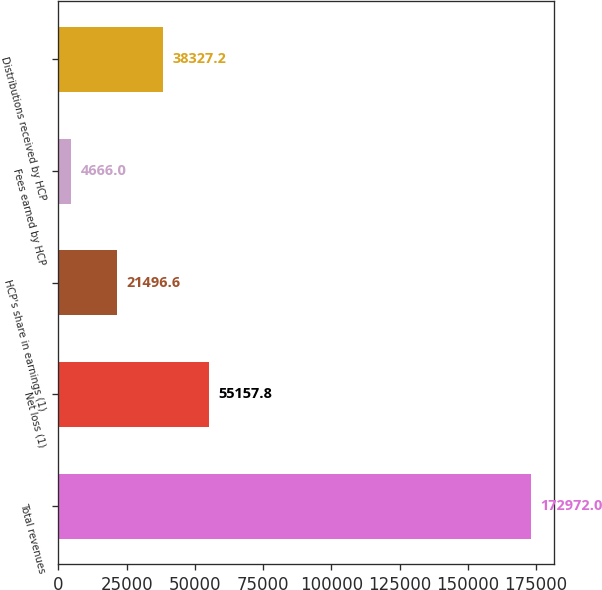Convert chart. <chart><loc_0><loc_0><loc_500><loc_500><bar_chart><fcel>Total revenues<fcel>Net loss (1)<fcel>HCP's share in earnings (1)<fcel>Fees earned by HCP<fcel>Distributions received by HCP<nl><fcel>172972<fcel>55157.8<fcel>21496.6<fcel>4666<fcel>38327.2<nl></chart> 